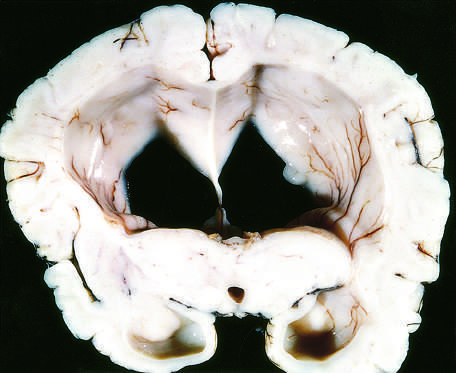what are associated with a dangerous increase in intra-cranial pressure?
Answer the question using a single word or phrase. Compression of the expanding brain 